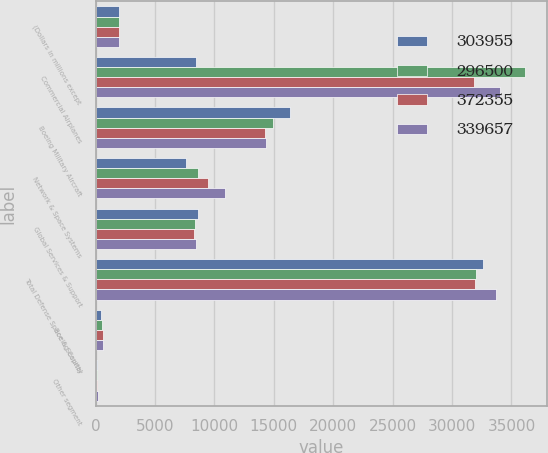<chart> <loc_0><loc_0><loc_500><loc_500><stacked_bar_chart><ecel><fcel>(Dollars in millions except<fcel>Commercial Airplanes<fcel>Boeing Military Aircraft<fcel>Network & Space Systems<fcel>Global Services & Support<fcel>Total Defense Space & Security<fcel>Boeing Capital<fcel>Other segment<nl><fcel>303955<fcel>2012<fcel>8486<fcel>16384<fcel>7584<fcel>8639<fcel>32607<fcel>441<fcel>133<nl><fcel>296500<fcel>2011<fcel>36171<fcel>14947<fcel>8654<fcel>8375<fcel>31976<fcel>520<fcel>150<nl><fcel>372355<fcel>2010<fcel>31834<fcel>14238<fcel>9449<fcel>8256<fcel>31943<fcel>639<fcel>138<nl><fcel>339657<fcel>2009<fcel>34051<fcel>14304<fcel>10871<fcel>8486<fcel>33661<fcel>660<fcel>165<nl></chart> 